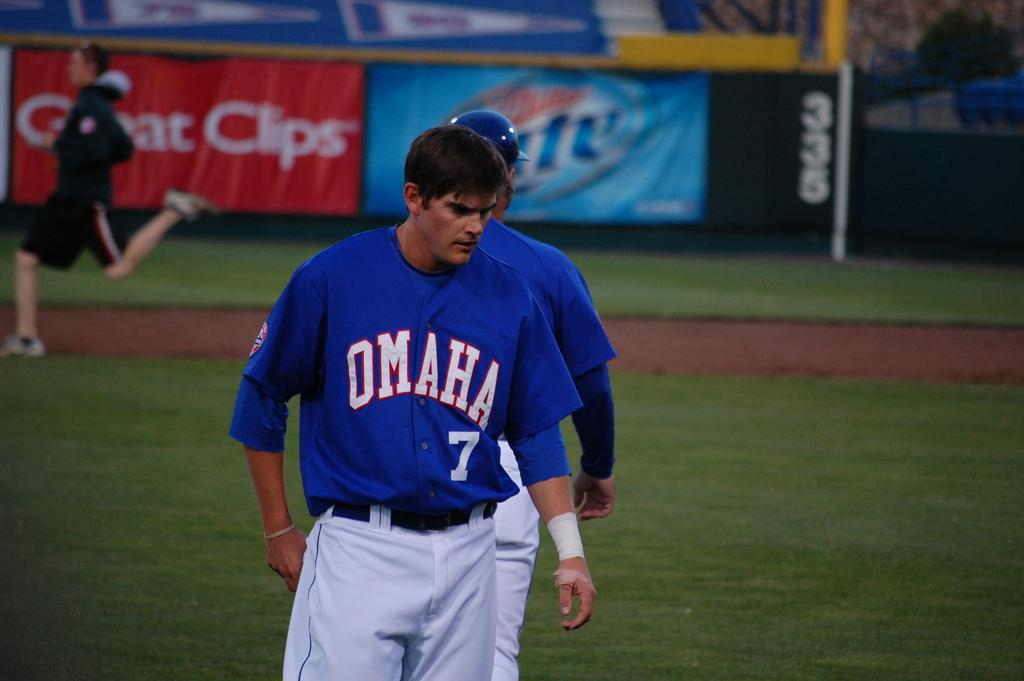<image>
Write a terse but informative summary of the picture. Two baseball players wit hthe omaha logo on ones chest and the number 7 below it. 